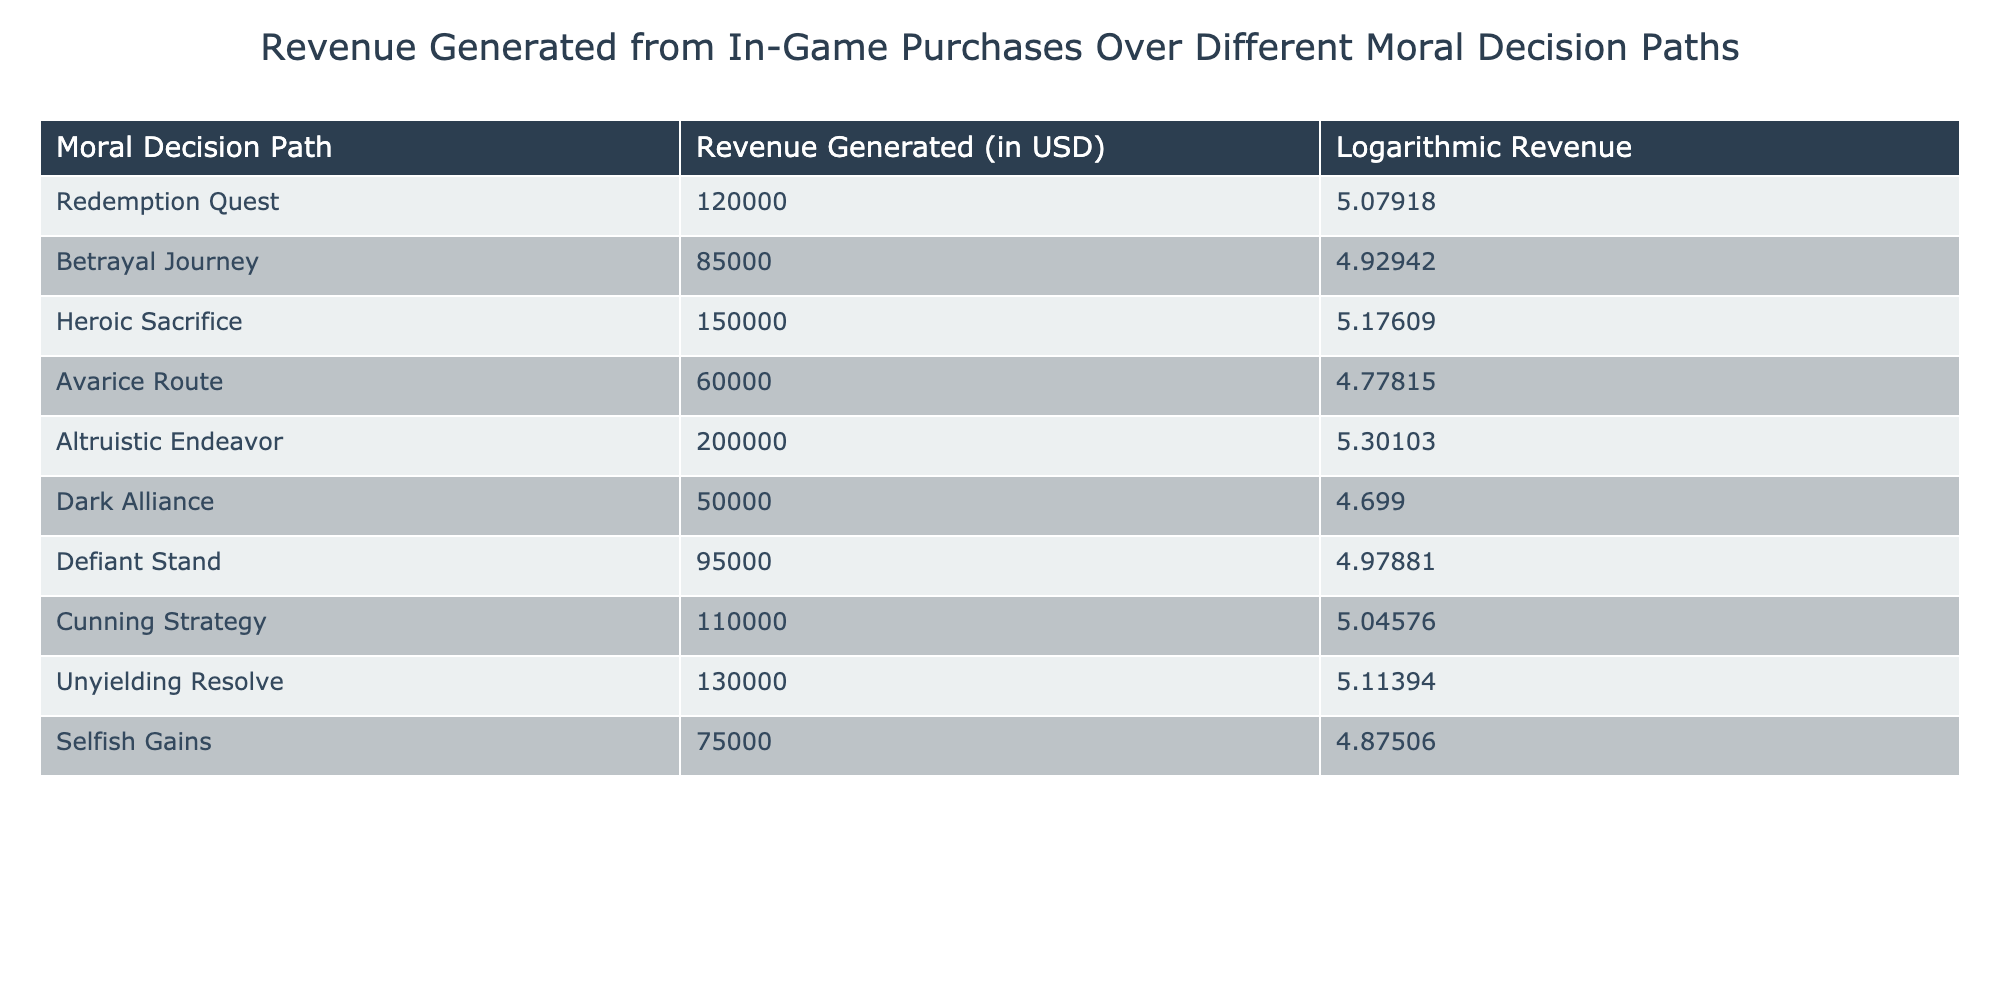What is the total revenue generated from the "Altruistic Endeavor" path? The revenue generated from "Altruistic Endeavor" path is listed in the table as 200000 USD.
Answer: 200000 USD What is the logarithmic revenue for the "Heroic Sacrifice" moral path? The logarithmic revenue for "Heroic Sacrifice" can be found directly in the table, which states that it is 5.17609.
Answer: 5.17609 Which moral decision path generated the least revenue from in-game purchases? By examining the revenue column, "Dark Alliance" shows the least revenue generated at 50000 USD, compared to others.
Answer: Dark Alliance Is the revenue generated from the "Betrayal Journey" greater than that from the "Selfish Gains"? Looking at the values, "Betrayal Journey" generated 85000 USD while "Selfish Gains" generated 75000 USD. Since 85000 is greater than 75000, the statement is true.
Answer: Yes What is the average revenue generated from the "Defiant Stand" and "Cunning Strategy"? The revenue for "Defiant Stand" is 95000 USD and for "Cunning Strategy" is 110000 USD. Summing these gives 95000 + 110000 = 205000. Dividing by 2 (the number of paths) yields 205000 / 2 = 102500.
Answer: 102500 USD Which two moral decision paths have logarithmic revenue values closest to each other? The logarithmic revenue values for "Redemption Quest" (5.07918) and "Cunning Strategy" (5.04576) are the closest. The difference between them is minimal, indicating they are closely related.
Answer: Redemption Quest and Cunning Strategy What is the difference in revenue between the "Avarice Route" and "Defiant Stand"? "Avarice Route" has a revenue of 60000 USD and "Defiant Stand" has 95000 USD. To find the difference, subtract 60000 from 95000, which gives 95000 - 60000 = 35000 USD.
Answer: 35000 USD Is it true that all moral decision paths except "Altruistic Endeavor" generated less than 200000 USD? By evaluating the revenue values in the table, "Altruistic Endeavor" is the only path with revenue over 200000 USD, while all others fall below this threshold. Thus, the statement is true.
Answer: Yes Which moral decision path has the highest logarithmic revenue? The path with the highest logarithmic revenue is "Altruistic Endeavor," with a value of 5.30103. This can be confirmed by comparing the logarithmic values presented in the table.
Answer: Altruistic Endeavor 